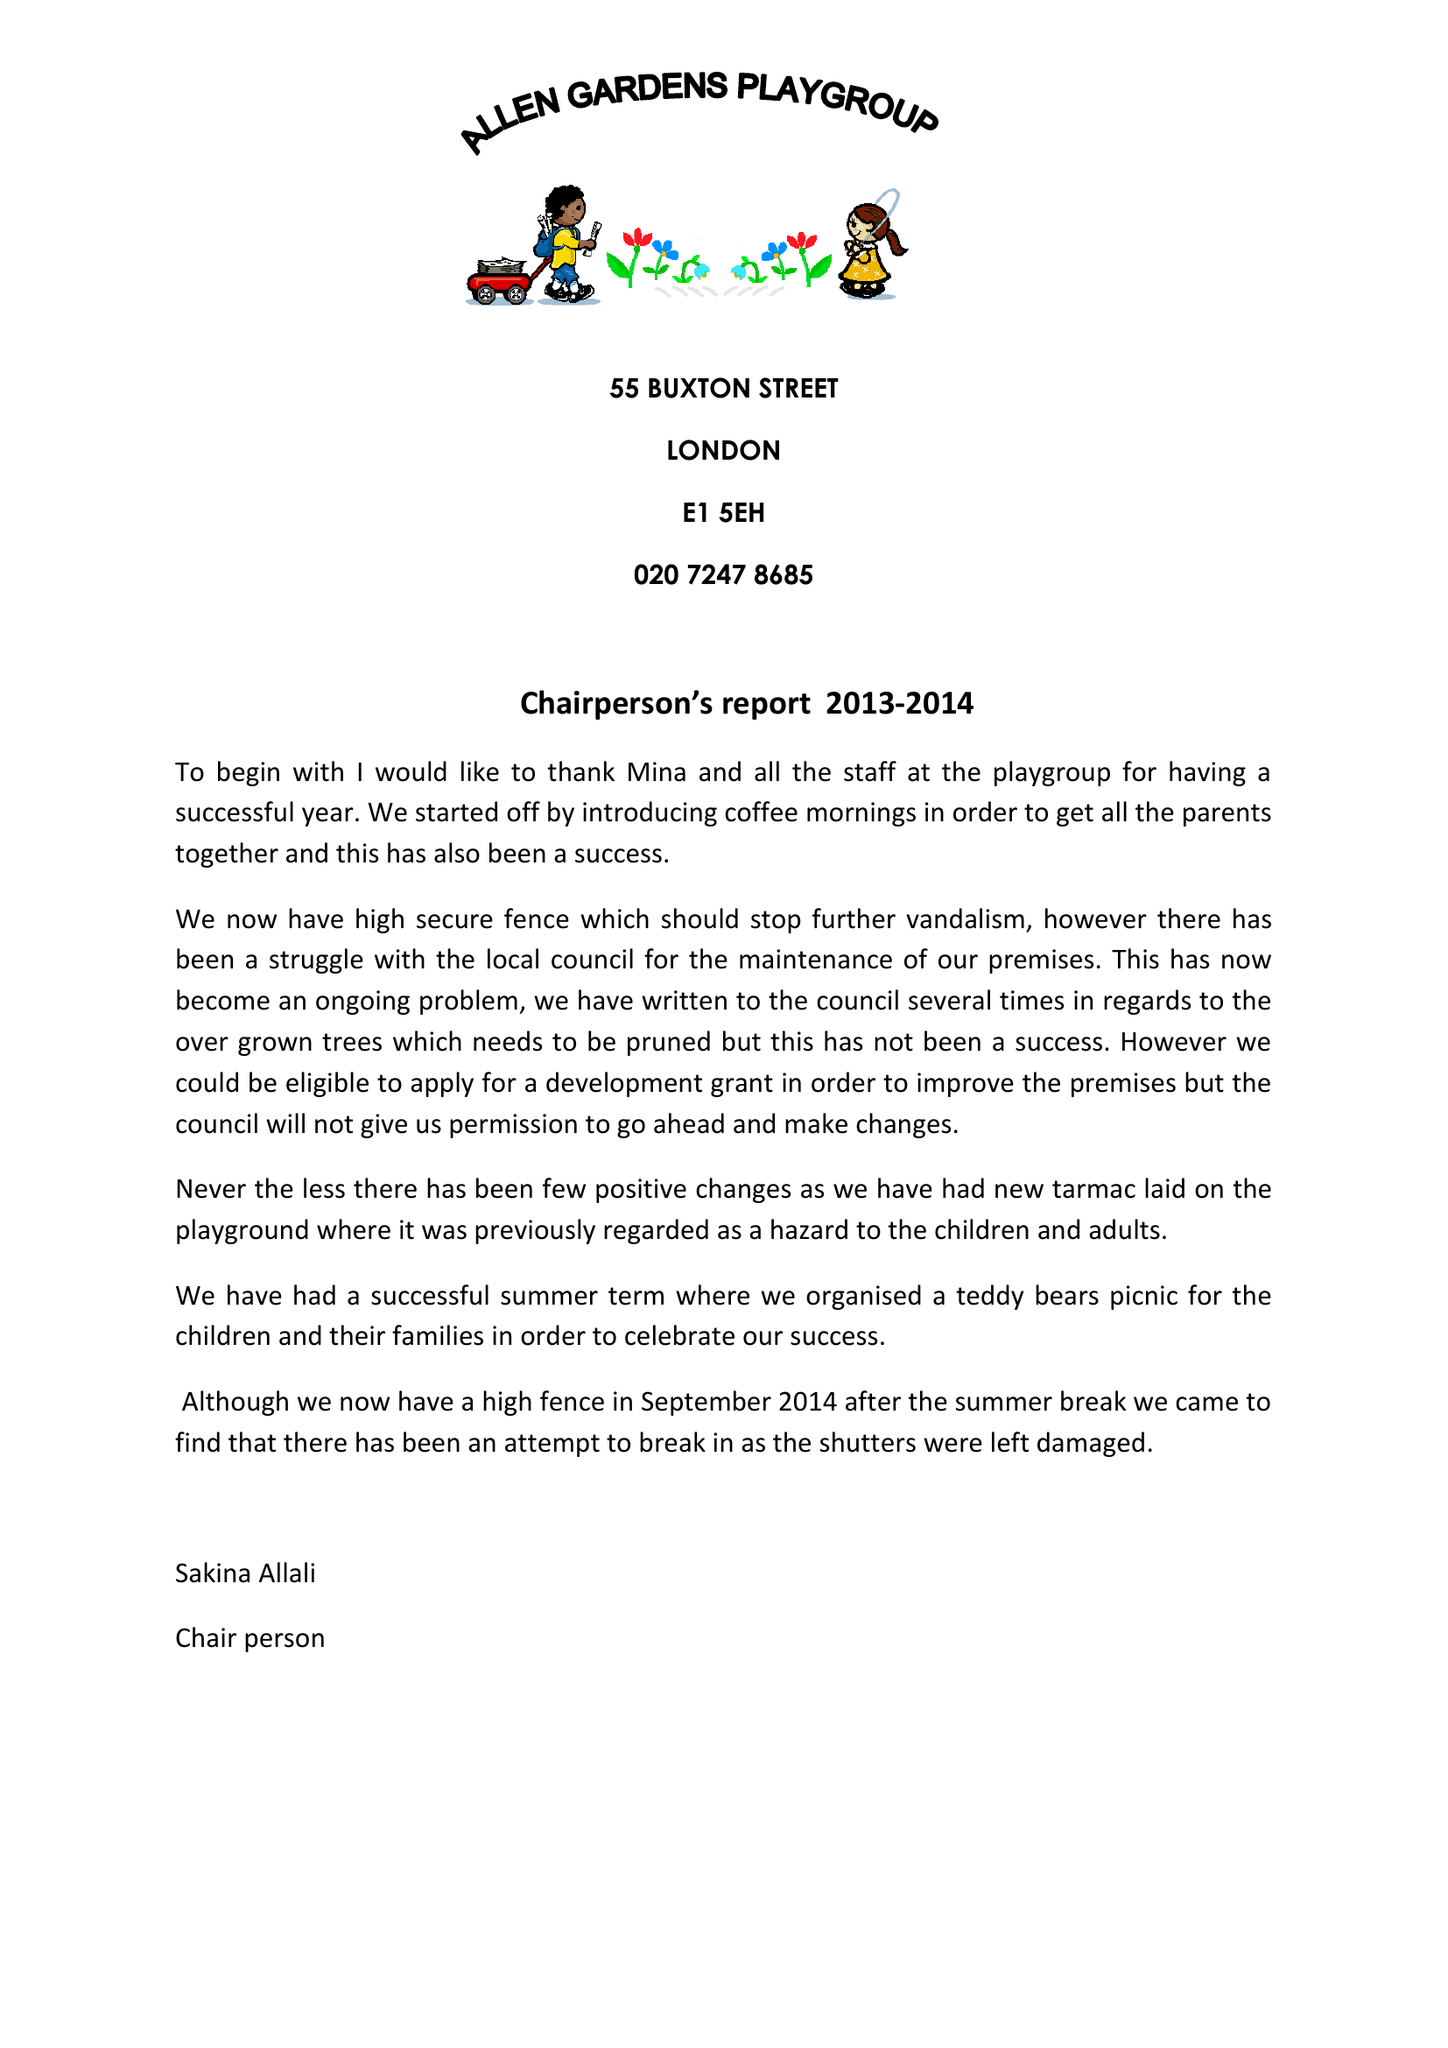What is the value for the charity_number?
Answer the question using a single word or phrase. 284187 